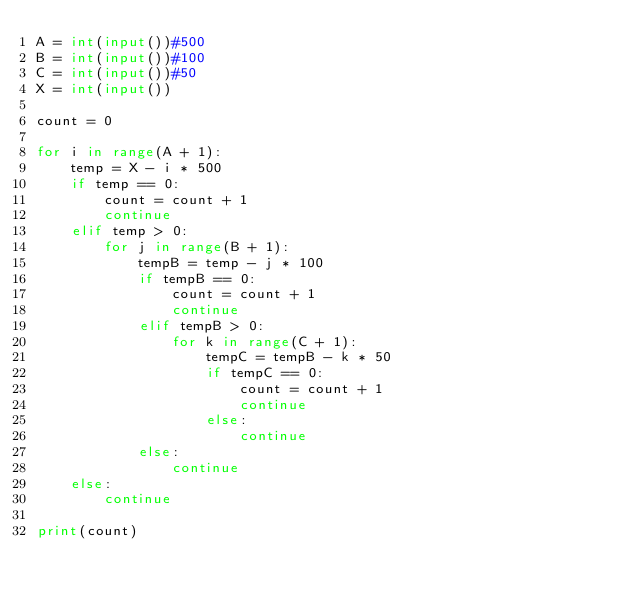<code> <loc_0><loc_0><loc_500><loc_500><_Python_>A = int(input())#500
B = int(input())#100
C = int(input())#50
X = int(input())

count = 0

for i in range(A + 1):
    temp = X - i * 500
    if temp == 0:
        count = count + 1
        continue
    elif temp > 0:
        for j in range(B + 1):
            tempB = temp - j * 100
            if tempB == 0:
                count = count + 1
                continue
            elif tempB > 0:
                for k in range(C + 1):
                    tempC = tempB - k * 50
                    if tempC == 0:
                        count = count + 1
                        continue
                    else:
                        continue
            else:
                continue
    else:
        continue

print(count)</code> 